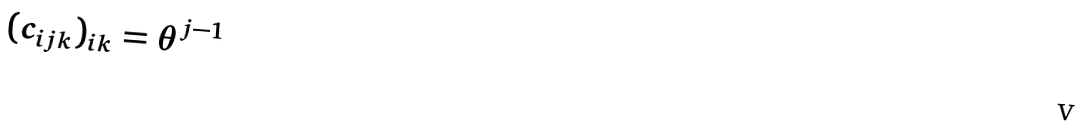Convert formula to latex. <formula><loc_0><loc_0><loc_500><loc_500>( c _ { i j k } ) _ { i k } = \theta ^ { j - 1 }</formula> 